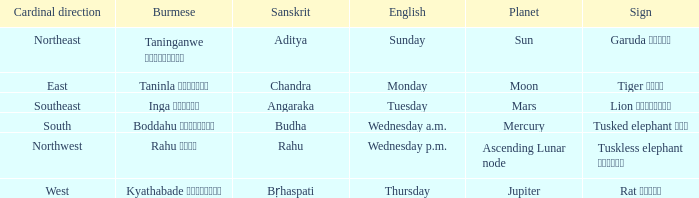Mention the english day name associated with the east cardinal direction. Monday. 